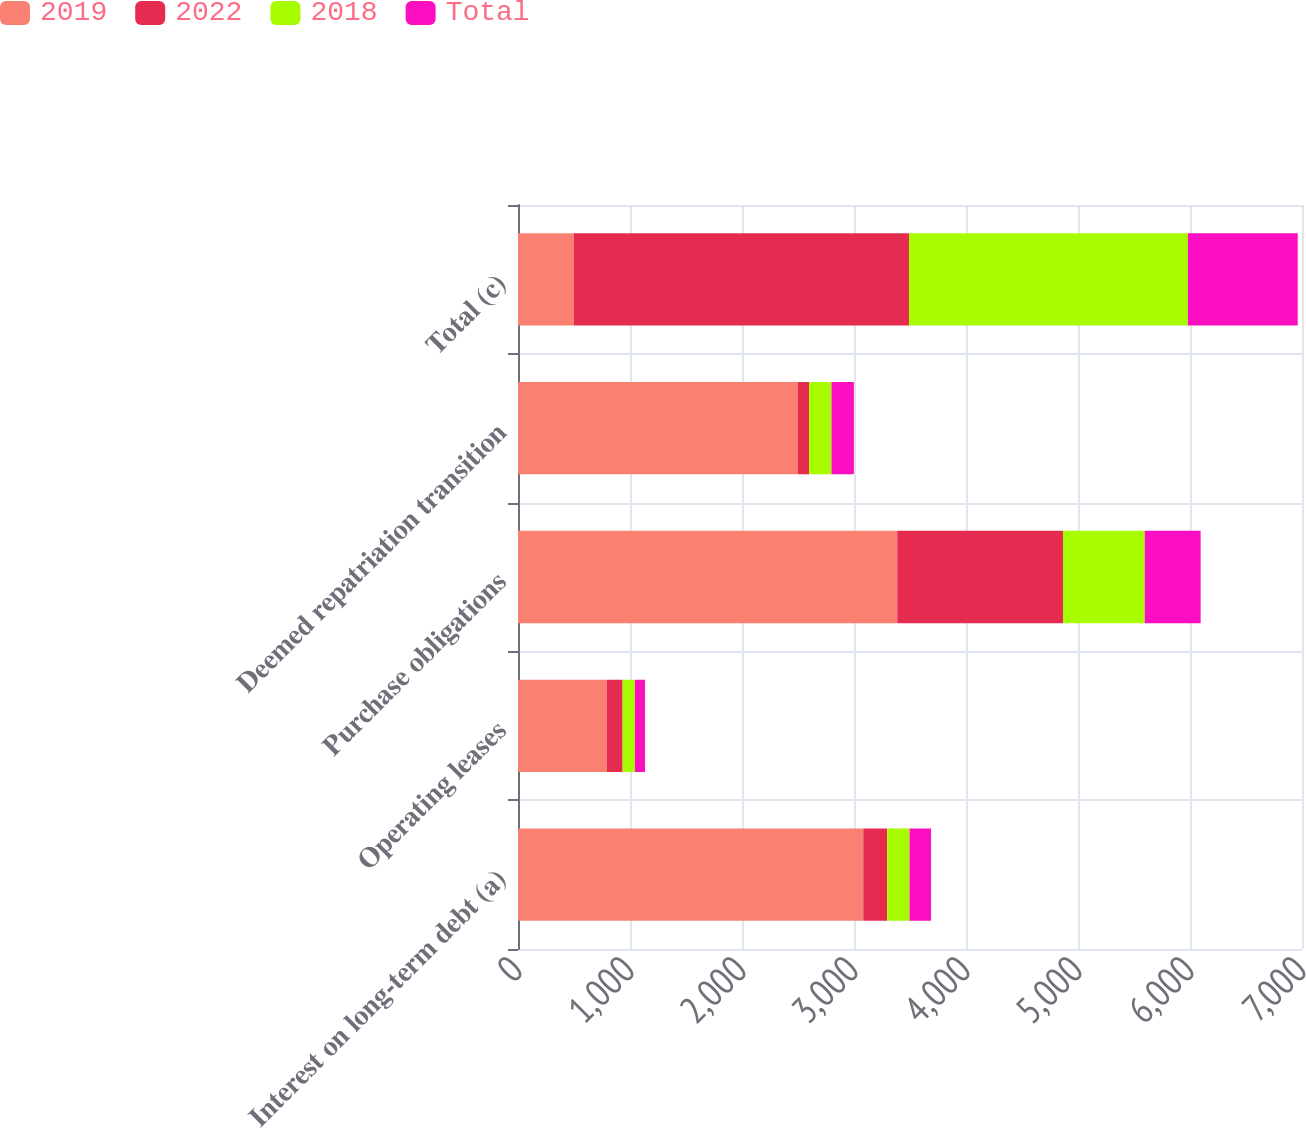Convert chart to OTSL. <chart><loc_0><loc_0><loc_500><loc_500><stacked_bar_chart><ecel><fcel>Interest on long-term debt (a)<fcel>Operating leases<fcel>Purchase obligations<fcel>Deemed repatriation transition<fcel>Total (c)<nl><fcel>2019<fcel>3083<fcel>793<fcel>3386<fcel>2497<fcel>499<nl><fcel>2022<fcel>213<fcel>141<fcel>1480<fcel>102<fcel>2992<nl><fcel>2018<fcel>200<fcel>110<fcel>730<fcel>200<fcel>2490<nl><fcel>Total<fcel>192<fcel>90<fcel>499<fcel>200<fcel>981<nl></chart> 